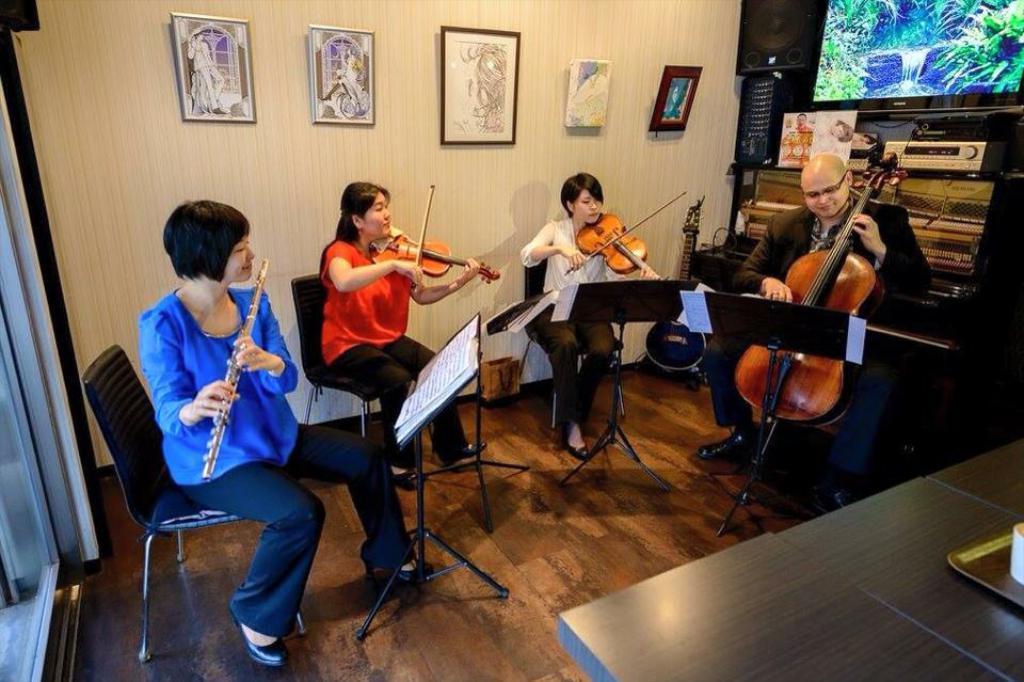Could you give a brief overview of what you see in this image? There are four members in this room sitting in the chairs in front of a stand on which a book was placed. Three of them were playing violin. One of the four members was playing a flute. In the background there is a wall to which some photographs were hanged. 